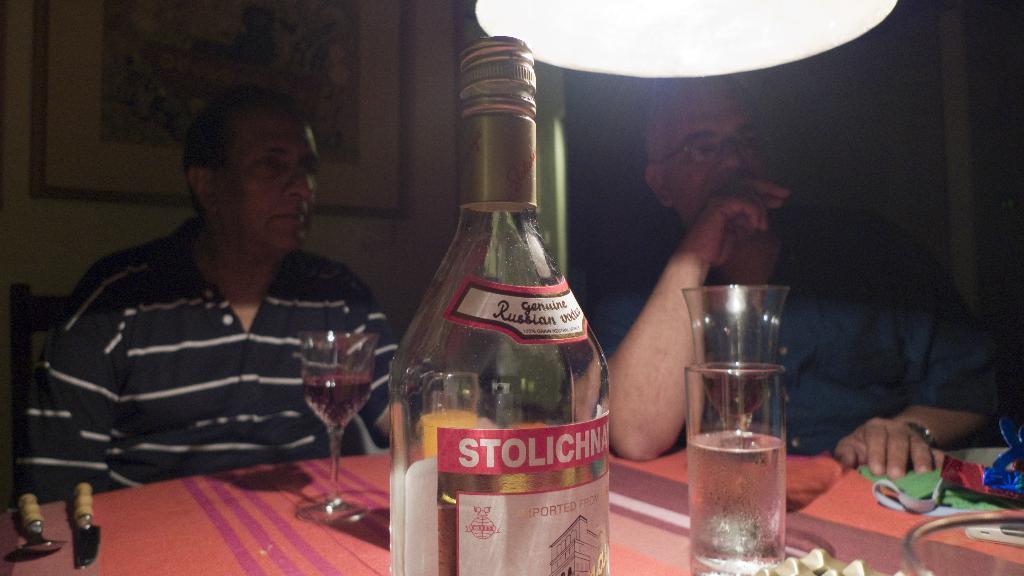Could you give a brief overview of what you see in this image? In this image there are two men sitting besides a table. Towards the left, there is a man and he is wearing a striped shirt. Towards the right he is wearing a blue shirt. On the table there are glasses and bottle. In the background there is a wall and a frame. 